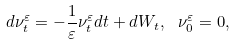<formula> <loc_0><loc_0><loc_500><loc_500>d \nu ^ { \varepsilon } _ { t } = - \frac { 1 } { \varepsilon } \nu ^ { \varepsilon } _ { t } d t + d W _ { t } , \ \nu ^ { \varepsilon } _ { 0 } = 0 ,</formula> 